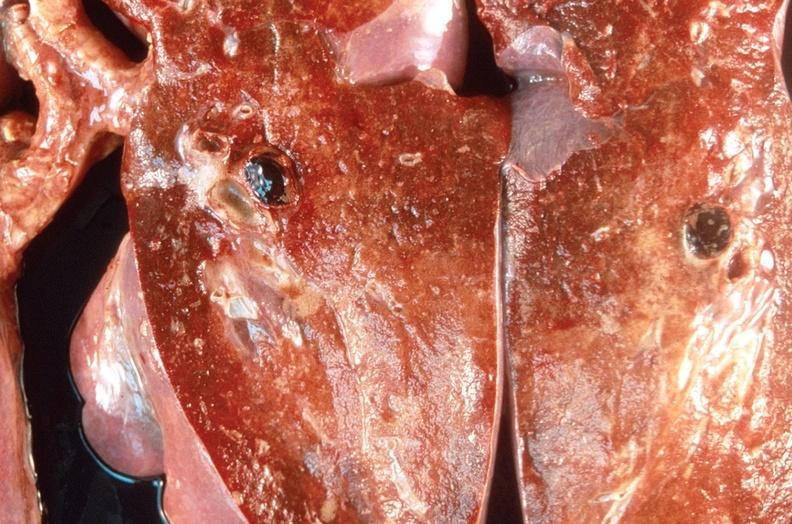where is this?
Answer the question using a single word or phrase. Lung 